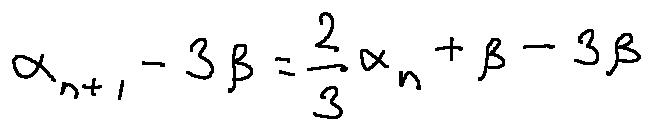<formula> <loc_0><loc_0><loc_500><loc_500>\alpha _ { n + 1 } - 3 \beta = \frac { 2 } { 3 } \alpha _ { n } + \beta - 3 \beta</formula> 